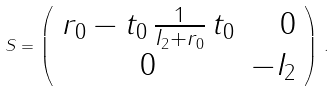Convert formula to latex. <formula><loc_0><loc_0><loc_500><loc_500>S = \left ( \begin{array} { c r } r _ { 0 } - t _ { 0 } \, \frac { 1 } { I _ { 2 } + r _ { 0 } } \, t _ { 0 } & 0 \\ 0 & - I _ { 2 } \end{array} \right ) \, .</formula> 